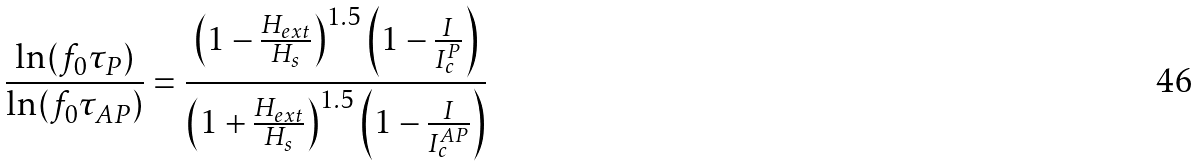Convert formula to latex. <formula><loc_0><loc_0><loc_500><loc_500>\frac { \ln ( f _ { 0 } \tau _ { P } ) } { \ln ( f _ { 0 } \tau _ { A P } ) } = \frac { \left ( 1 - \frac { H _ { e x t } } { H _ { s } } \right ) ^ { 1 . 5 } \left ( 1 - \frac { I } { I _ { c } ^ { P } } \right ) } { \left ( 1 + \frac { H _ { e x t } } { H _ { s } } \right ) ^ { 1 . 5 } \left ( 1 - \frac { I } { I _ { c } ^ { A P } } \right ) }</formula> 